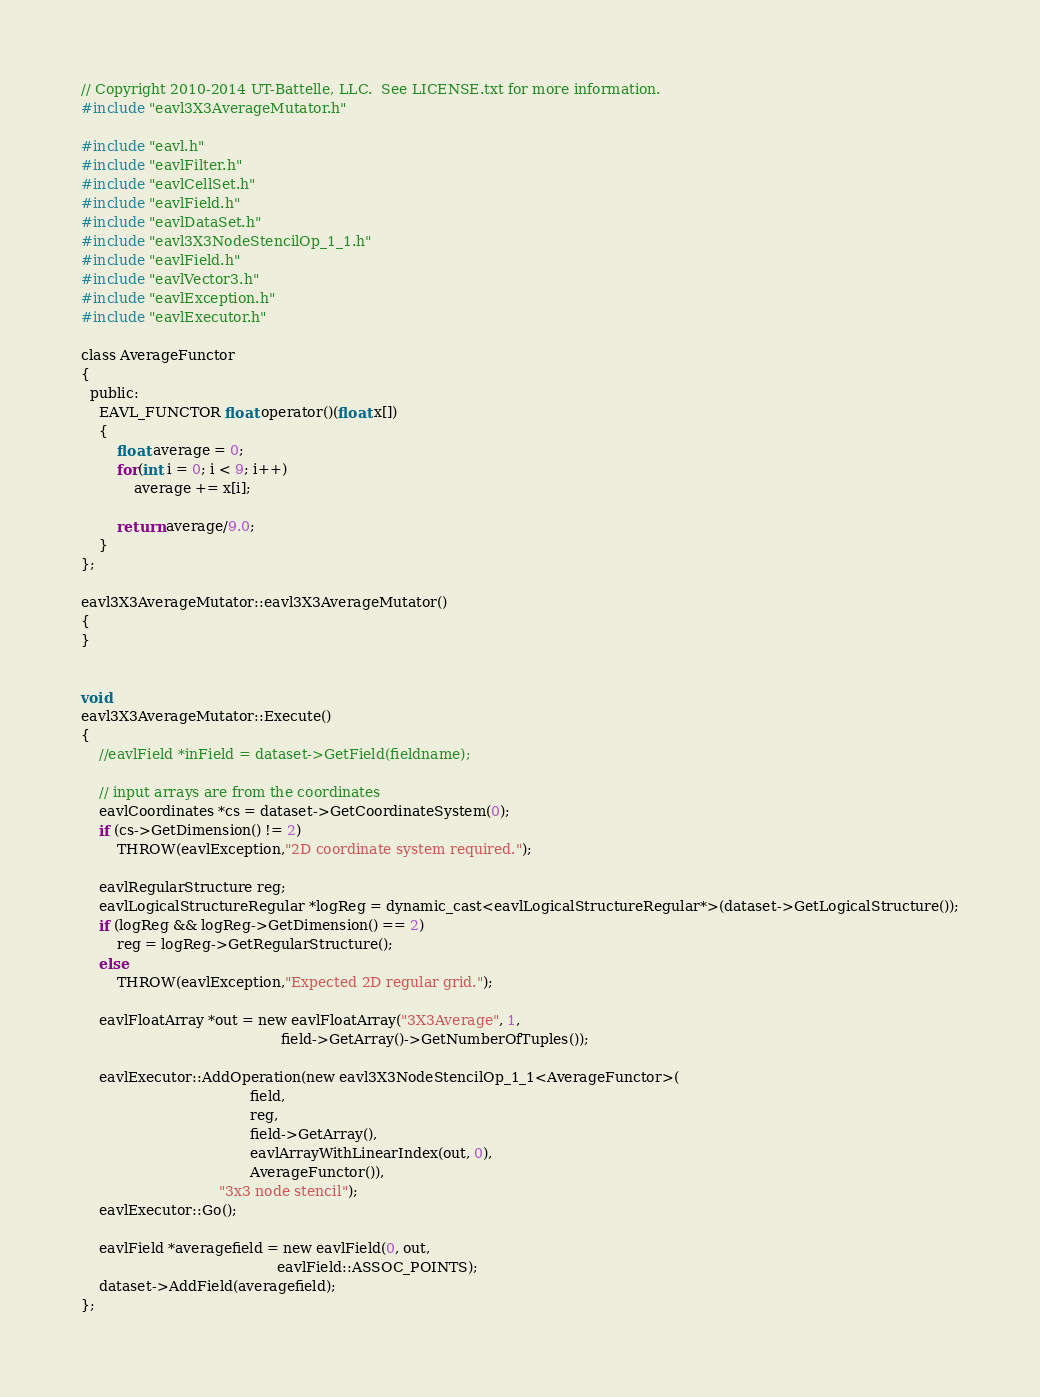Convert code to text. <code><loc_0><loc_0><loc_500><loc_500><_Cuda_>// Copyright 2010-2014 UT-Battelle, LLC.  See LICENSE.txt for more information.
#include "eavl3X3AverageMutator.h"

#include "eavl.h"
#include "eavlFilter.h"
#include "eavlCellSet.h"
#include "eavlField.h"
#include "eavlDataSet.h"
#include "eavl3X3NodeStencilOp_1_1.h"
#include "eavlField.h"
#include "eavlVector3.h"
#include "eavlException.h"
#include "eavlExecutor.h"

class AverageFunctor
{
  public:
    EAVL_FUNCTOR float operator()(float x[])
    {
        float average = 0;
        for(int i = 0; i < 9; i++)
            average += x[i];

        return average/9.0;
    }
};

eavl3X3AverageMutator::eavl3X3AverageMutator()
{
}


void
eavl3X3AverageMutator::Execute()
{
    //eavlField *inField = dataset->GetField(fieldname);

    // input arrays are from the coordinates
    eavlCoordinates *cs = dataset->GetCoordinateSystem(0);
    if (cs->GetDimension() != 2)
        THROW(eavlException,"2D coordinate system required.");

    eavlRegularStructure reg;
    eavlLogicalStructureRegular *logReg = dynamic_cast<eavlLogicalStructureRegular*>(dataset->GetLogicalStructure());
    if (logReg && logReg->GetDimension() == 2)
        reg = logReg->GetRegularStructure();
    else
        THROW(eavlException,"Expected 2D regular grid.");

    eavlFloatArray *out = new eavlFloatArray("3X3Average", 1,
                                             field->GetArray()->GetNumberOfTuples());

    eavlExecutor::AddOperation(new eavl3X3NodeStencilOp_1_1<AverageFunctor>(
                                      field,
                                      reg,
                                      field->GetArray(),
                                      eavlArrayWithLinearIndex(out, 0),
                                      AverageFunctor()),
                               "3x3 node stencil");
    eavlExecutor::Go();

    eavlField *averagefield = new eavlField(0, out,
                                            eavlField::ASSOC_POINTS);
    dataset->AddField(averagefield);
};
</code> 